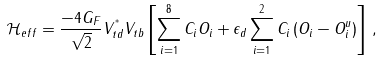Convert formula to latex. <formula><loc_0><loc_0><loc_500><loc_500>\mathcal { H } _ { e f f } = \frac { - 4 G _ { F } } { \sqrt { 2 } } V _ { t d } ^ { ^ { * } } V _ { t b } \left [ \sum _ { i = 1 } ^ { 8 } C _ { i } O _ { i } + \epsilon _ { d } \sum _ { i = 1 } ^ { 2 } C _ { i } \left ( O _ { i } - O _ { i } ^ { u } \right ) \right ] \, ,</formula> 